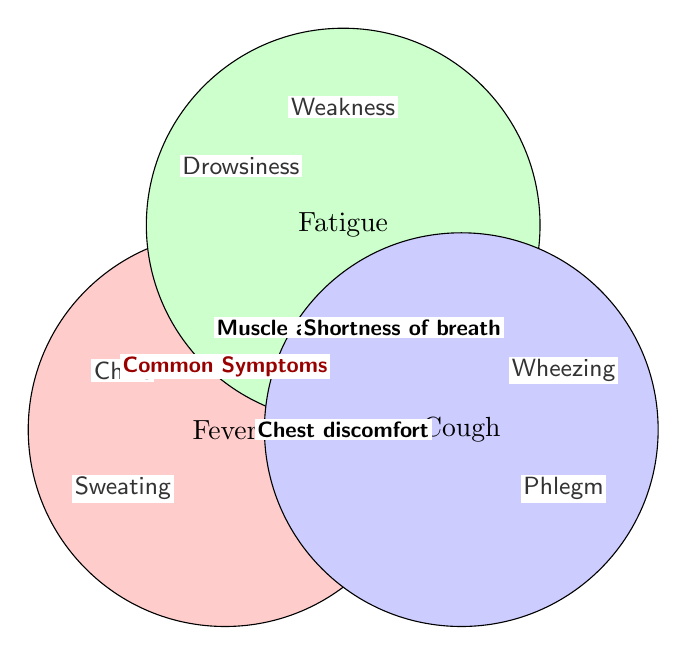what is the color of the fever circle? The fever circle is filled with a light red shade.
Answer: Red What symptoms are exclusive to fever? Exclusive symptoms are located within the Fever circle but outside any overlaps. These are Chills and Sweating.
Answer: Chills, Sweating Which symptom is common to both fever and fatigue? The symptom placed in the overlapping area between the Fever and Fatigue circles is Muscle aches.
Answer: Muscle aches Are there any symptoms common to all three conditions? Symptoms common to all three conditions would be in the center overlapping all three circles.
Answer: No What symptom is found at the overlap of fatigue and cough? The symptom placed in the overlapping area between the Fatigue and Cough circles is Shortness of breath.
Answer: Shortness of breath How many intersections are there in the diagram? Count the areas where two or more circles overlap. There are three intersections: Fever and Fatigue, Fatigue and Cough, Fever and Cough.
Answer: Three Which symptom appears in the cough circle but not in any overlaps? Exclusive symptoms are placed within the Cough circle but outside any overlaps. These are Wheezing and Phlegm production.
Answer: Wheezing, Phlegm production Which conditions share the least number of common symptoms? Compare the number of symptoms in the overlap areas of any two conditions. Fever and Cough have the least with one common symptom.
Answer: Fever and Cough What is the common symptom between fever and cough? The symptom located in the overlapping area between the Fever and Cough circles is Chest discomfort.
Answer: Chest discomfort What is the total number of symptoms exclusive to only one condition? Count exclusive symptoms for each circle: Fever (2), Fatigue (2), Cough (2). Add them up: 2 + 2 + 2 = 6.
Answer: Six 